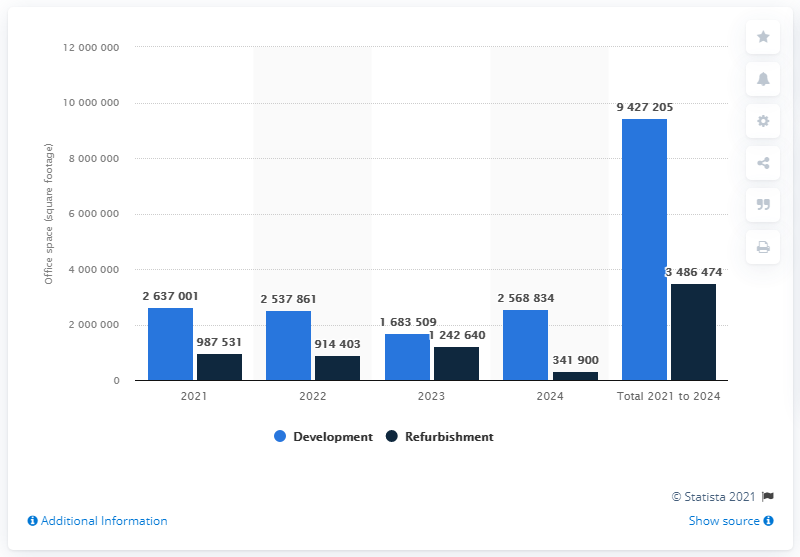Identify some key points in this picture. By 2024, the volume of refurbished office space in London's West End is expected to reach approximately 348,647,474 square feet. Approximately 263,7001 square feet of new office space is expected to be developed between 2021 and 2024. According to our research, it is expected that approximately 9,427,205 square feet of new office space will be developed between 2021 and 2024. 